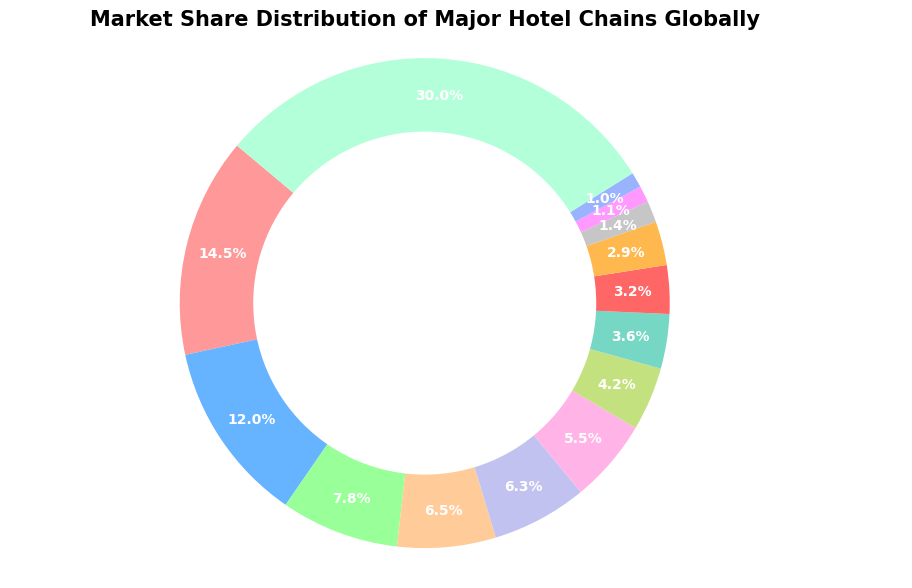What hotel chain has the highest market share globally? Marriott International has the highest market share. This can be seen because its slice of the pie chart is the largest and has a label indicating a 14.5% market share.
Answer: Marriott International What is the combined market share of Hilton Worldwide and IHG (InterContinental Hotels Group)? To find the combined market share of Hilton Worldwide and IHG, we add 12.0% (Hilton Worldwide) and 7.8% (IHG). This results in 12.0 + 7.8 = 19.8%.
Answer: 19.8% Which hotel chain has a smaller market share: Radisson Hotel Group or Hyatt Hotels Corporation? By looking at their slices in the pie chart, Radisson Hotel Group has a smaller market share (3.2%) compared to Hyatt Hotels Corporation (3.6%).
Answer: Radisson Hotel Group What is the market share difference between AccorHotels and Wyndham Hotels & Resorts? The market share of Wyndham Hotels & Resorts is 6.5%, and AccorHotels has 6.3%. The difference is calculated by subtracting the smaller percentage from the larger one: 6.5 - 6.3 = 0.2%.
Answer: 0.2% What percentage of the market share is dominated by chains outside the top 13 listed? The "Other" category accounts for the market share of chains not listed among the top 13. Its market share is shown in the pie chart as 30.0%.
Answer: 30.0% Which hotel chain has the second-highest market share and what is that percentage? The second-largest slice in the pie chart belongs to Hilton Worldwide, which has a market share of 12.0%.
Answer: Hilton Worldwide with 12.0% What is the total market share of the bottom five hotel chains on the list? The bottom five hotel chains are Plaza International Hotels (1.4%), Extended Stay America (1.1%), Motel 6 (G6 Hospitality) (1.0%), and Best Western Hotels & Resorts (2.9%). Their combined market share is 1.4 + 1.1 + 1.0 + 2.9 = 6.4%.
Answer: 6.4% How does the market share of Choice Hotels compare to the market share of Jin Jiang International? Choice Hotels has a market share of 5.5%, while Jin Jiang International has 4.2%. Choice Hotels has a larger market share when compared with Jin Jiang International.
Answer: Choice Hotels is larger What is the average market share of the hotel chains with more than a 6% market share each? The chains with more than a 6% market share are Marriott International (14.5%), Hilton Worldwide (12.0%), IHG (7.8%), Wyndham Hotels & Resorts (6.5%), and AccorHotels (6.3%). The average market share is calculated as: (14.5 + 12.0 + 7.8 + 6.5 + 6.3) / 5 = 9.42%.
Answer: 9.42% Which colors represent Hyatt Hotels Corporation and Radisson Hotel Group’s market shares on the pie chart? In the pie chart, Hyatt Hotels Corporation is assigned a green slice, while Radisson Hotel Group is assigned a red slice. This can be seen by matching the slices to their labels in the visual.
Answer: Hyatt: green, Radisson: red 